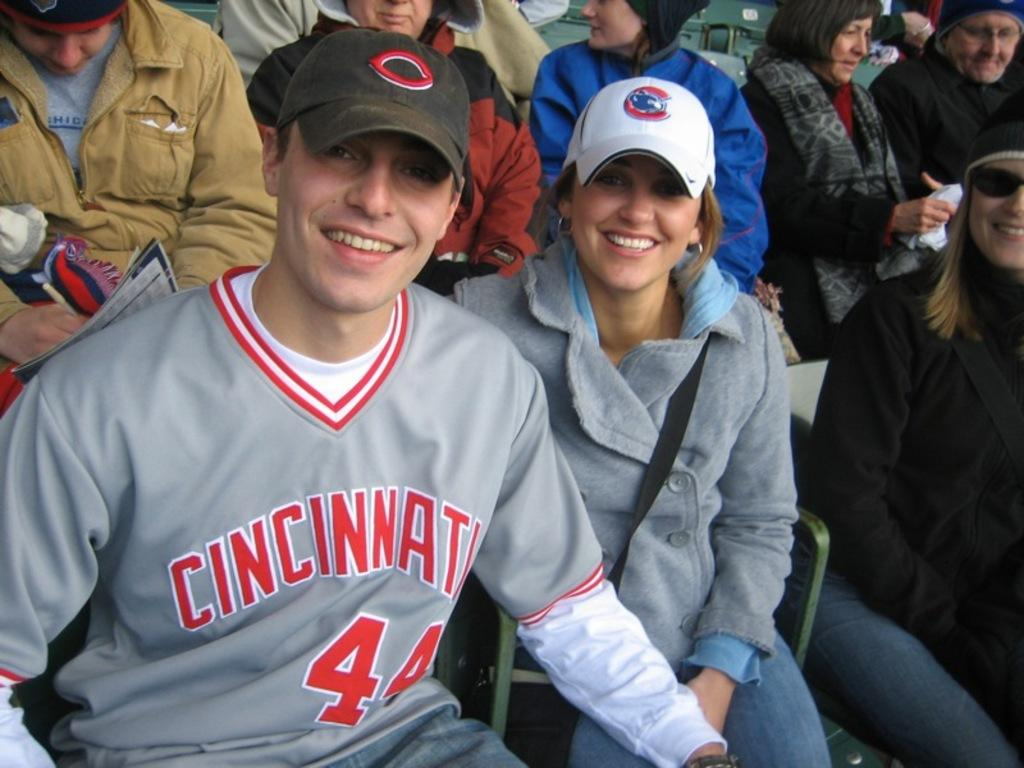<image>
Offer a succinct explanation of the picture presented. Two people pose for a picture - the man is wearing a grey jersey that reads CINCINNATI 